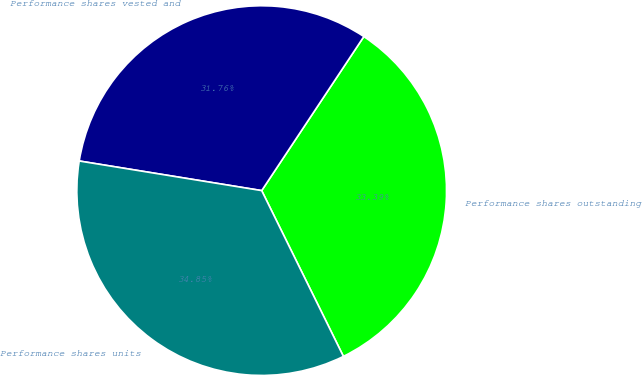Convert chart. <chart><loc_0><loc_0><loc_500><loc_500><pie_chart><fcel>Performance shares outstanding<fcel>Performance shares vested and<fcel>Performance shares units<nl><fcel>33.39%<fcel>31.76%<fcel>34.85%<nl></chart> 